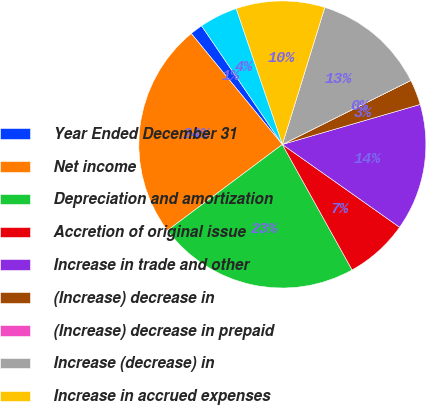<chart> <loc_0><loc_0><loc_500><loc_500><pie_chart><fcel>Year Ended December 31<fcel>Net income<fcel>Depreciation and amortization<fcel>Accretion of original issue<fcel>Increase in trade and other<fcel>(Increase) decrease in<fcel>(Increase) decrease in prepaid<fcel>Increase (decrease) in<fcel>Increase in accrued expenses<fcel>Increase in customer deposits<nl><fcel>1.43%<fcel>24.28%<fcel>22.85%<fcel>7.14%<fcel>14.28%<fcel>2.86%<fcel>0.0%<fcel>12.86%<fcel>10.0%<fcel>4.29%<nl></chart> 